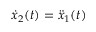<formula> <loc_0><loc_0><loc_500><loc_500>{ \dot { x } } _ { 2 } ( t ) = { \ddot { x } } _ { 1 } ( t )</formula> 